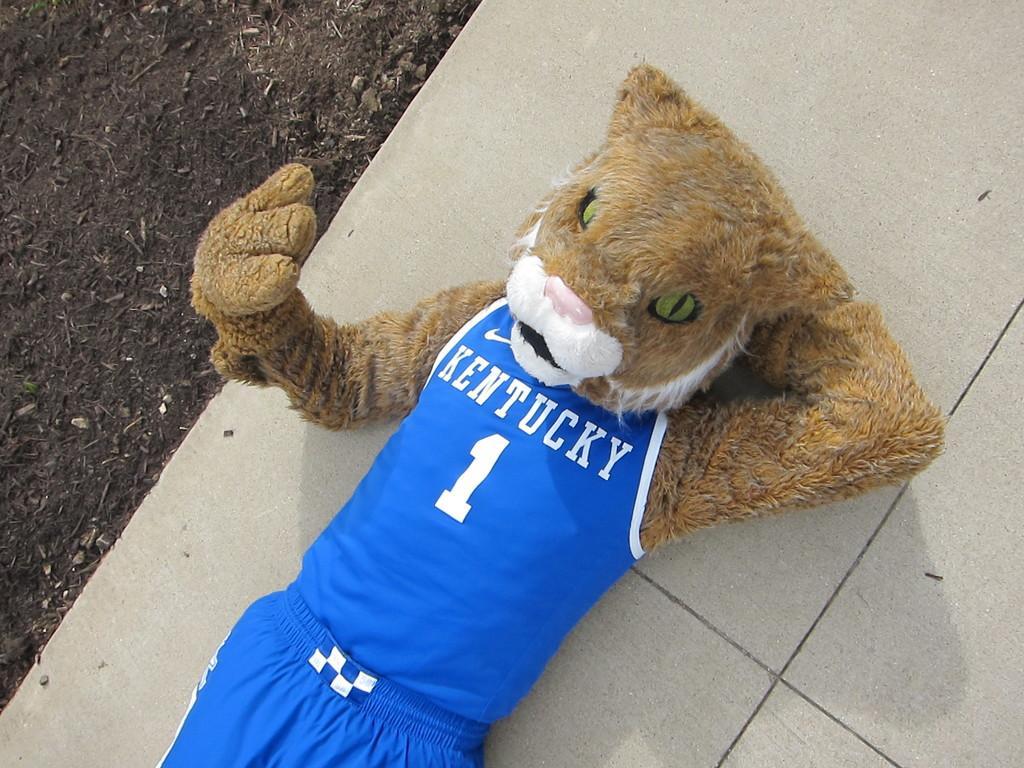Describe this image in one or two sentences. In this image we can see a toy. There is some text printed on the T-shirt. 